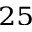<formula> <loc_0><loc_0><loc_500><loc_500>^ { 2 5 }</formula> 